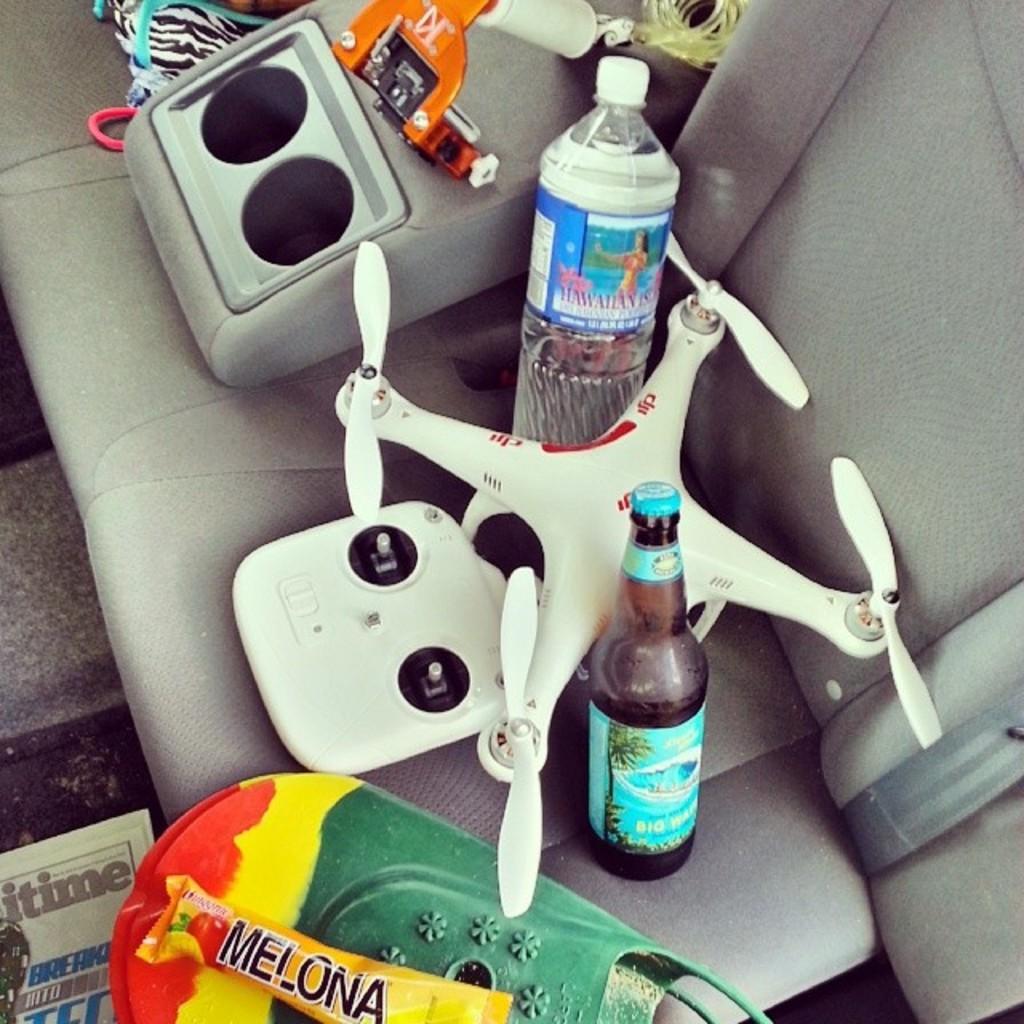What brand of water is in the bottle?
Give a very brief answer. Hawaiian. 